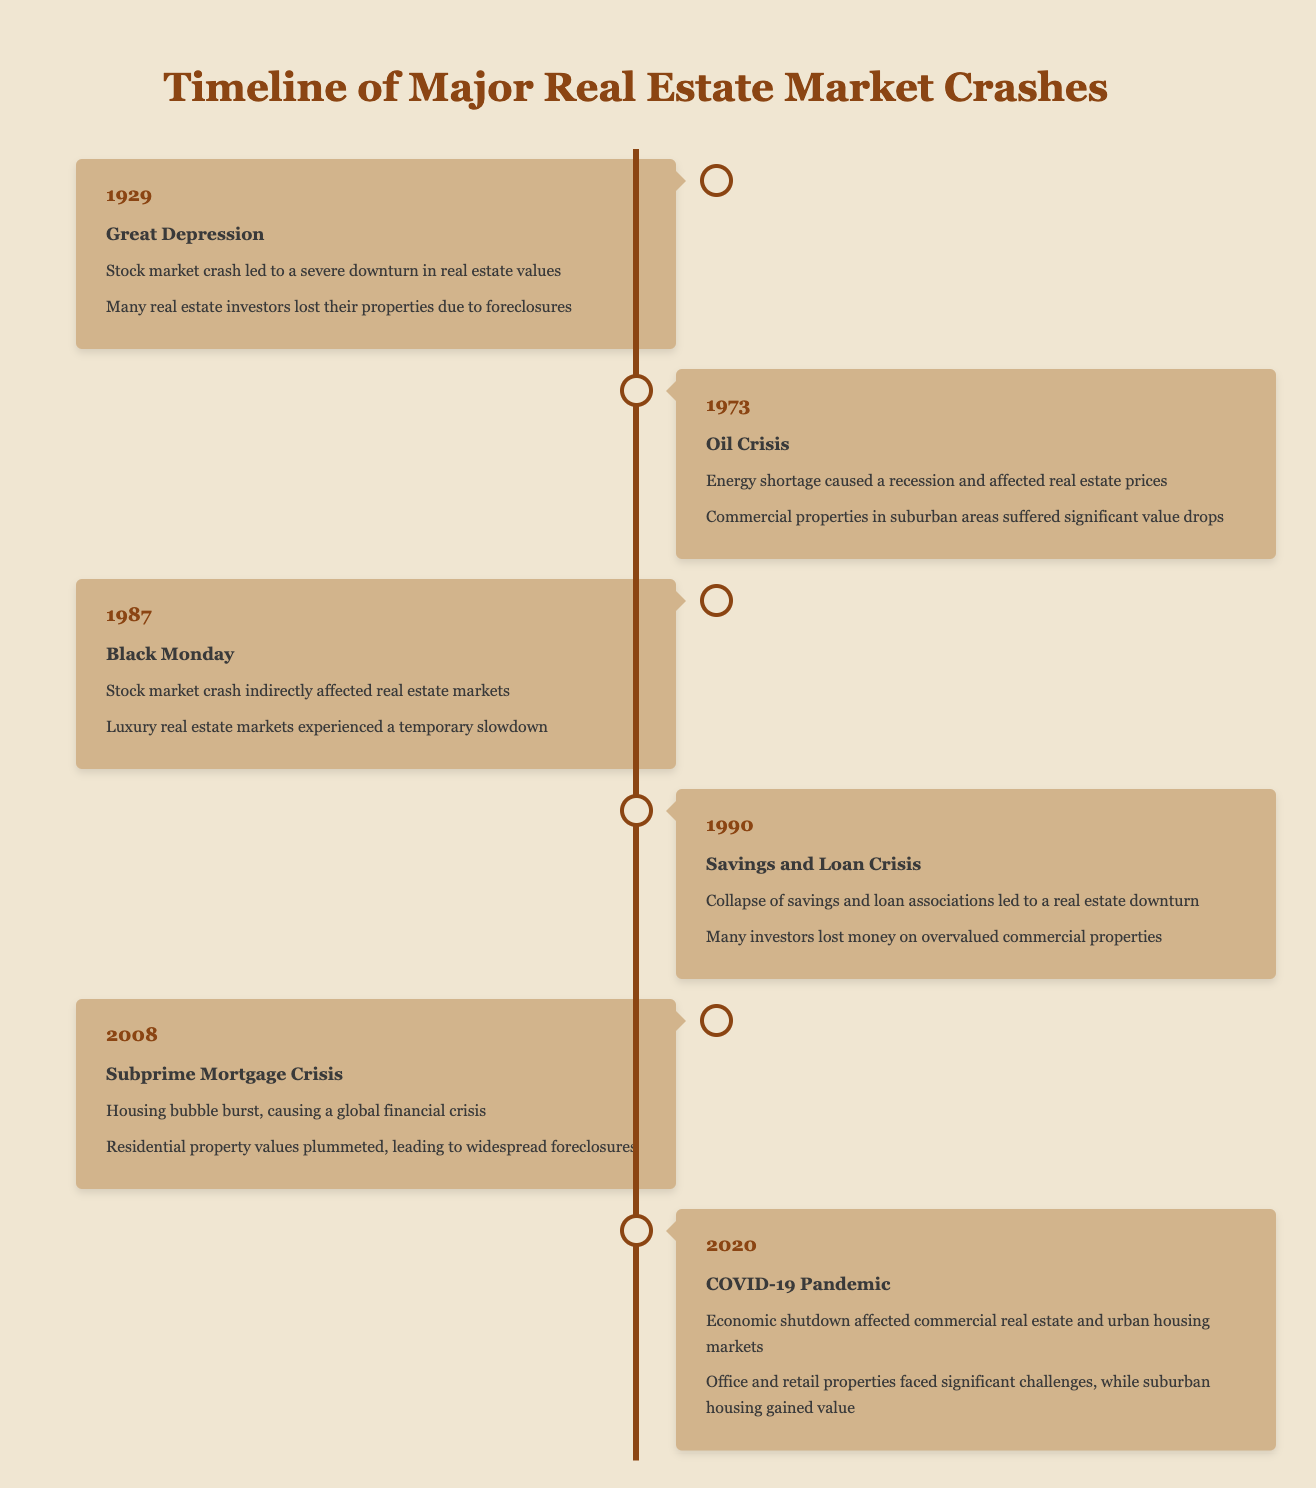What event caused many real estate investors to lose their properties in 1929? The table states that the event in 1929 was the Great Depression, which led to foreclosures for many investors.
Answer: Great Depression In which year did the Oil Crisis occur? The timeline indicates that the Oil Crisis took place in 1973.
Answer: 1973 How many major real estate market crashes are listed in the table? The table provides a total of six events related to real estate market crashes from 1929 to 2020.
Answer: 6 Which two events directly impacted residential property values leading to widespread foreclosures? The events related to residential property values and foreclosures are the Subprime Mortgage Crisis in 2008 and the Great Depression in 1929.
Answer: Subprime Mortgage Crisis and Great Depression True or False: The Black Monday event in 1987 caused significant value drops in suburban commercial properties. The table indicates that Black Monday did lead to a temporary slowdown in luxury real estate markets, but it does not mention suburban commercial properties specifically. Therefore, the answer is false.
Answer: False What is the impact on investors during the COVID-19 Pandemic event in 2020 regarding suburban housing? According to the table, suburban housing gained value during the COVID-19 Pandemic, contrasting with the struggles faced by office and retail properties.
Answer: Suburban housing gained value List the events in chronological order that negatively impacted commercial properties. The events listed that negatively impacted commercial properties are: Oil Crisis in 1973, Black Monday in 1987, Savings and Loan Crisis in 1990, and COVID-19 Pandemic in 2020.
Answer: Oil Crisis, Black Monday, Savings and Loan Crisis, COVID-19 Pandemic What was the main cause behind the Savings and Loan Crisis in 1990? The table describes the Savings and Loan Crisis as the collapse of savings and loan associations leading to a real estate downturn.
Answer: Collapse of savings and loan associations Which event had the most recent impact on the real estate market? The timeline shows that the most recent event is the COVID-19 Pandemic which occurred in 2020.
Answer: COVID-19 Pandemic How did the impact on investors differ between the Great Depression and the COVID-19 Pandemic? During the Great Depression, many investors lost their properties due to foreclosures, whereas during the COVID-19 Pandemic, investors faced significant challenges mainly in office and retail properties, while suburban housing gained value.
Answer: Different impacts: foreclosures in Great Depression, suburban gain in COVID-19 Pandemic 